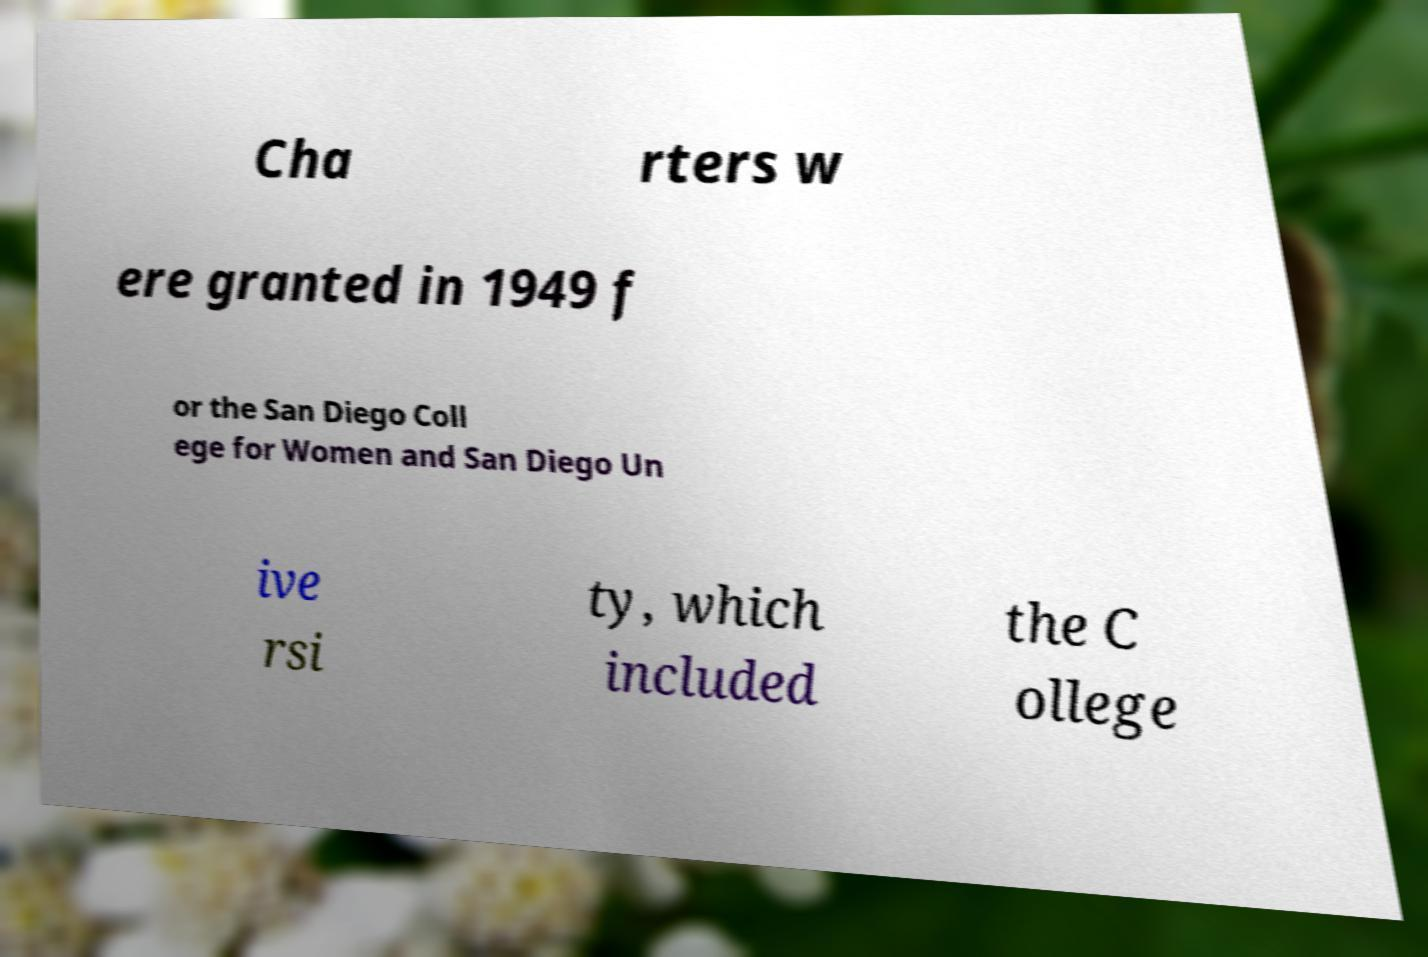For documentation purposes, I need the text within this image transcribed. Could you provide that? Cha rters w ere granted in 1949 f or the San Diego Coll ege for Women and San Diego Un ive rsi ty, which included the C ollege 